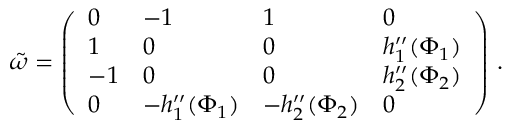Convert formula to latex. <formula><loc_0><loc_0><loc_500><loc_500>\begin{array} { r } { \tilde { \omega } = \left ( \begin{array} { l l l l } { 0 } & { - 1 } & { 1 } & { 0 } \\ { 1 } & { 0 } & { 0 } & { h _ { 1 } ^ { \prime \prime } ( \Phi _ { 1 } ) } \\ { - 1 } & { 0 } & { 0 } & { h _ { 2 } ^ { \prime \prime } ( \Phi _ { 2 } ) } \\ { 0 } & { - h _ { 1 } ^ { \prime \prime } ( \Phi _ { 1 } ) } & { - h _ { 2 } ^ { \prime \prime } ( \Phi _ { 2 } ) } & { 0 } \end{array} \right ) \, . } \end{array}</formula> 